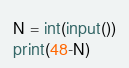<code> <loc_0><loc_0><loc_500><loc_500><_Python_>N = int(input())
print(48-N)</code> 